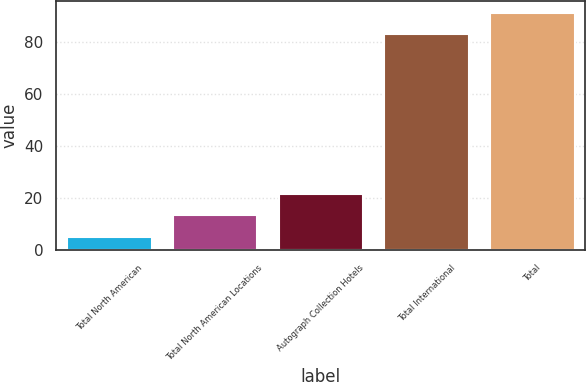Convert chart to OTSL. <chart><loc_0><loc_0><loc_500><loc_500><bar_chart><fcel>Total North American<fcel>Total North American Locations<fcel>Autograph Collection Hotels<fcel>Total International<fcel>Total<nl><fcel>5<fcel>13.3<fcel>21.6<fcel>83<fcel>91.3<nl></chart> 